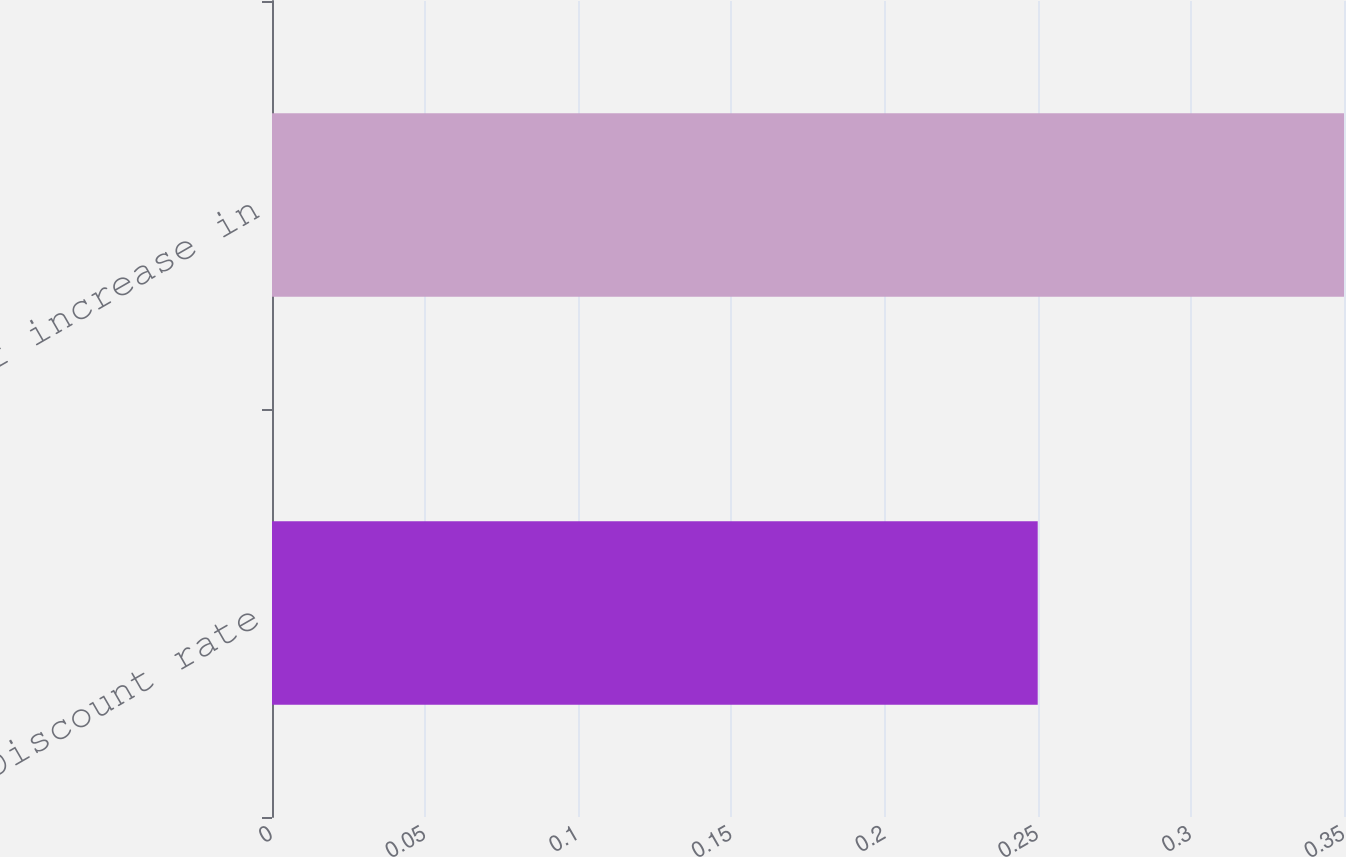Convert chart to OTSL. <chart><loc_0><loc_0><loc_500><loc_500><bar_chart><fcel>Discount rate<fcel>Rate of increase in<nl><fcel>0.25<fcel>0.35<nl></chart> 